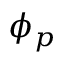Convert formula to latex. <formula><loc_0><loc_0><loc_500><loc_500>\phi _ { p }</formula> 